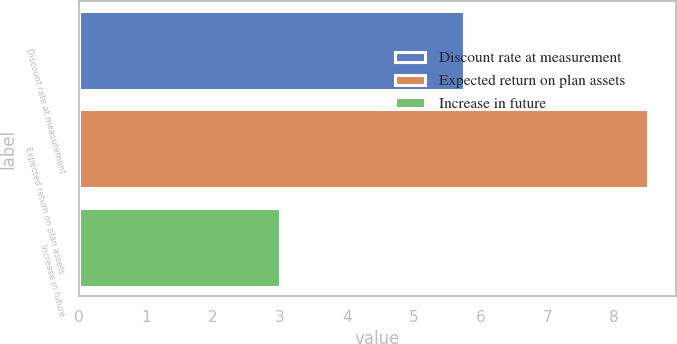Convert chart. <chart><loc_0><loc_0><loc_500><loc_500><bar_chart><fcel>Discount rate at measurement<fcel>Expected return on plan assets<fcel>Increase in future<nl><fcel>5.75<fcel>8.5<fcel>3<nl></chart> 